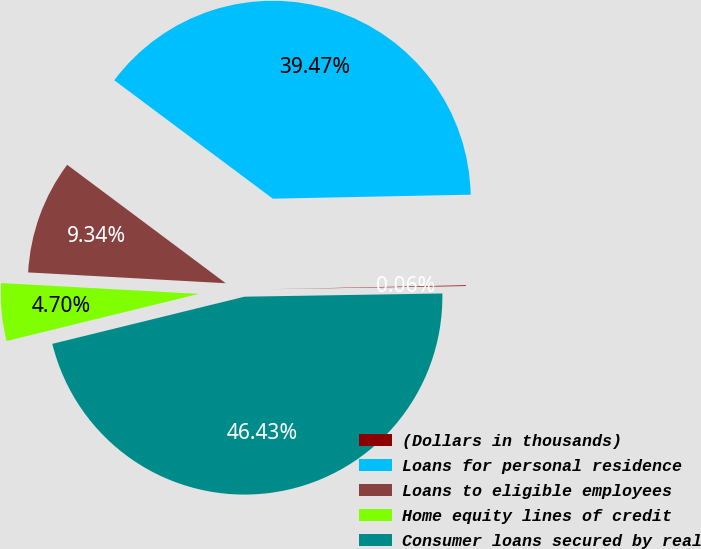Convert chart to OTSL. <chart><loc_0><loc_0><loc_500><loc_500><pie_chart><fcel>(Dollars in thousands)<fcel>Loans for personal residence<fcel>Loans to eligible employees<fcel>Home equity lines of credit<fcel>Consumer loans secured by real<nl><fcel>0.06%<fcel>39.47%<fcel>9.34%<fcel>4.7%<fcel>46.43%<nl></chart> 